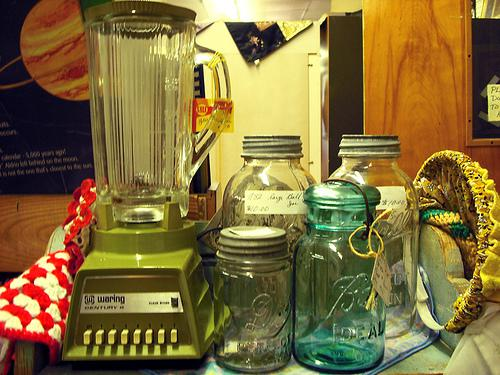Question: what item is directly to the left of the jars?
Choices:
A. Toaster.
B. Microwave.
C. Blender.
D. Stove.
Answer with the letter. Answer: C Question: how many jars are there?
Choices:
A. Four.
B. Six.
C. Eight.
D. Ten.
Answer with the letter. Answer: A Question: what is depicted on the poster behind the blender?
Choices:
A. Planet.
B. Basketball Player.
C. Band.
D. Actress.
Answer with the letter. Answer: A Question: what color is the blender?
Choices:
A. White.
B. Brown.
C. Yellow.
D. Green.
Answer with the letter. Answer: D Question: how many white buttons are on the blender?
Choices:
A. Ten.
B. Four.
C. Eight.
D. Six.
Answer with the letter. Answer: C Question: where is the red and white item in reference to the photo?
Choices:
A. Bottom left.
B. Top Right.
C. Directly Above.
D. Upper Right.
Answer with the letter. Answer: A Question: what color is the planet on the poster?
Choices:
A. Blue.
B. Green.
C. Red.
D. Orange.
Answer with the letter. Answer: D 